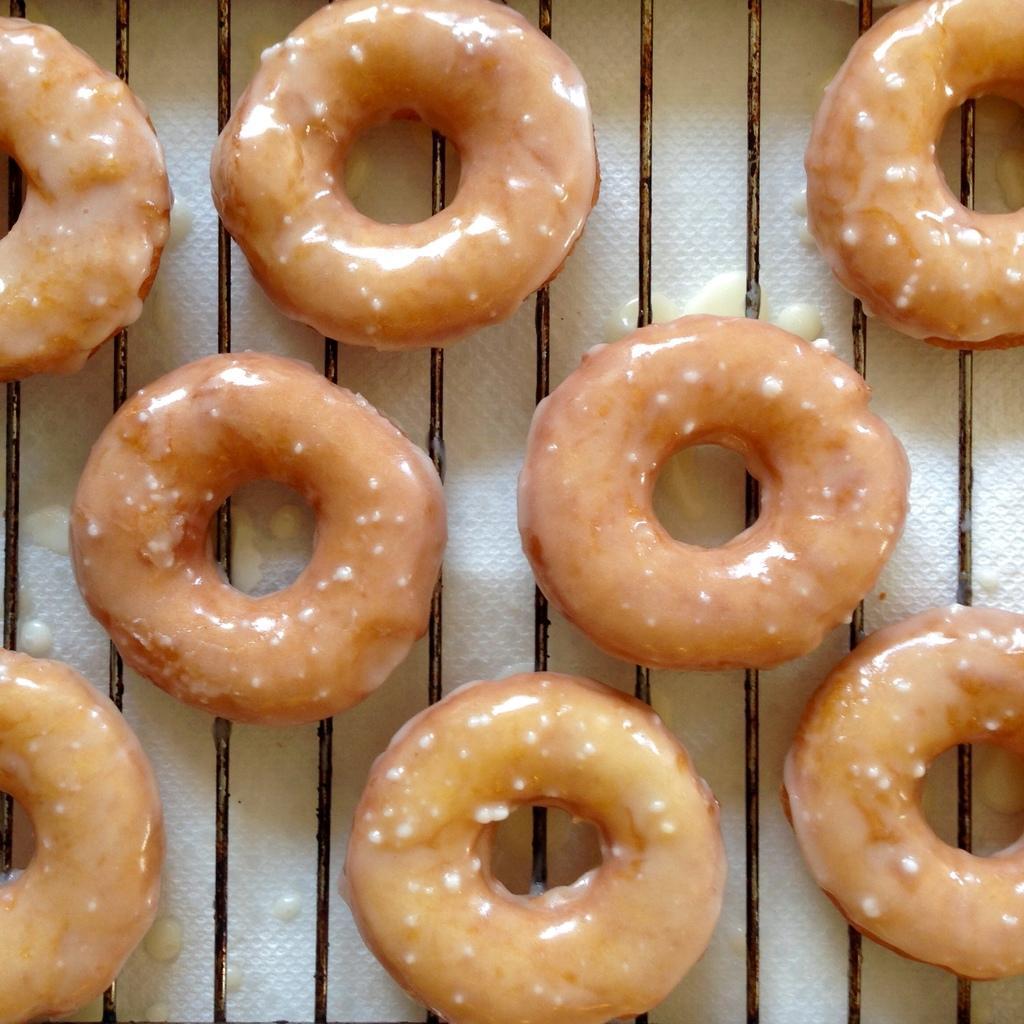In one or two sentences, can you explain what this image depicts? This image consists of doughnuts which are in the center. 